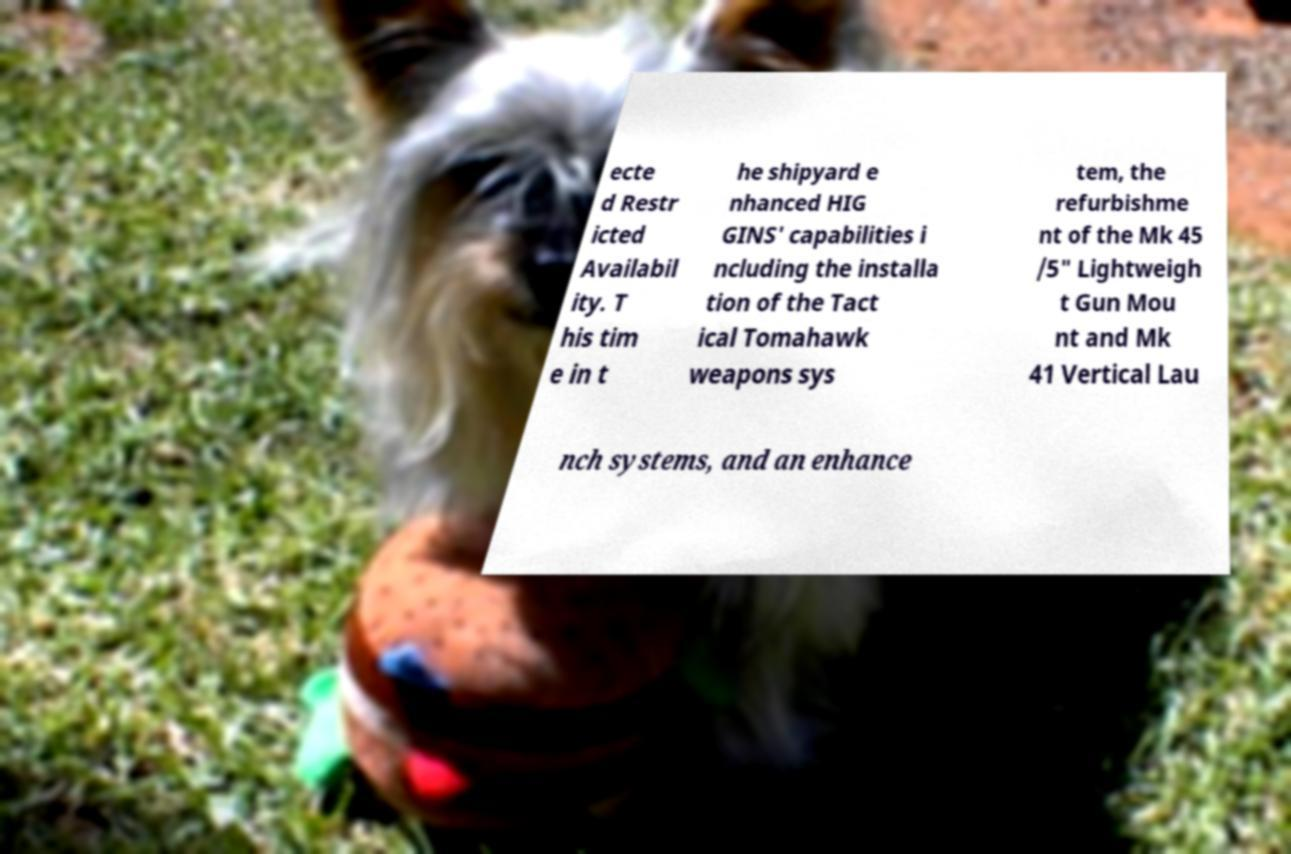Could you assist in decoding the text presented in this image and type it out clearly? ecte d Restr icted Availabil ity. T his tim e in t he shipyard e nhanced HIG GINS' capabilities i ncluding the installa tion of the Tact ical Tomahawk weapons sys tem, the refurbishme nt of the Mk 45 /5" Lightweigh t Gun Mou nt and Mk 41 Vertical Lau nch systems, and an enhance 